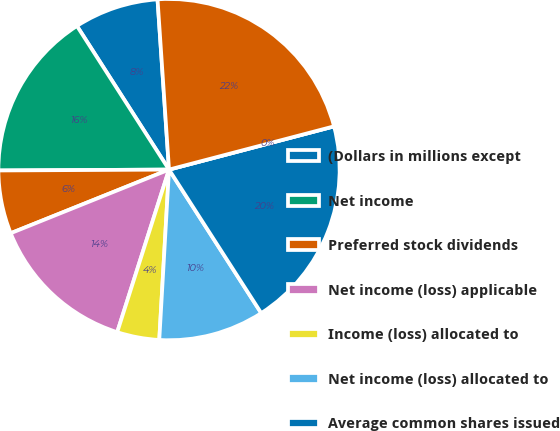<chart> <loc_0><loc_0><loc_500><loc_500><pie_chart><fcel>(Dollars in millions except<fcel>Net income<fcel>Preferred stock dividends<fcel>Net income (loss) applicable<fcel>Income (loss) allocated to<fcel>Net income (loss) allocated to<fcel>Average common shares issued<fcel>Earnings (loss) per common<fcel>Total diluted average common<nl><fcel>8.0%<fcel>16.01%<fcel>6.0%<fcel>14.01%<fcel>4.0%<fcel>10.0%<fcel>19.99%<fcel>0.0%<fcel>21.99%<nl></chart> 